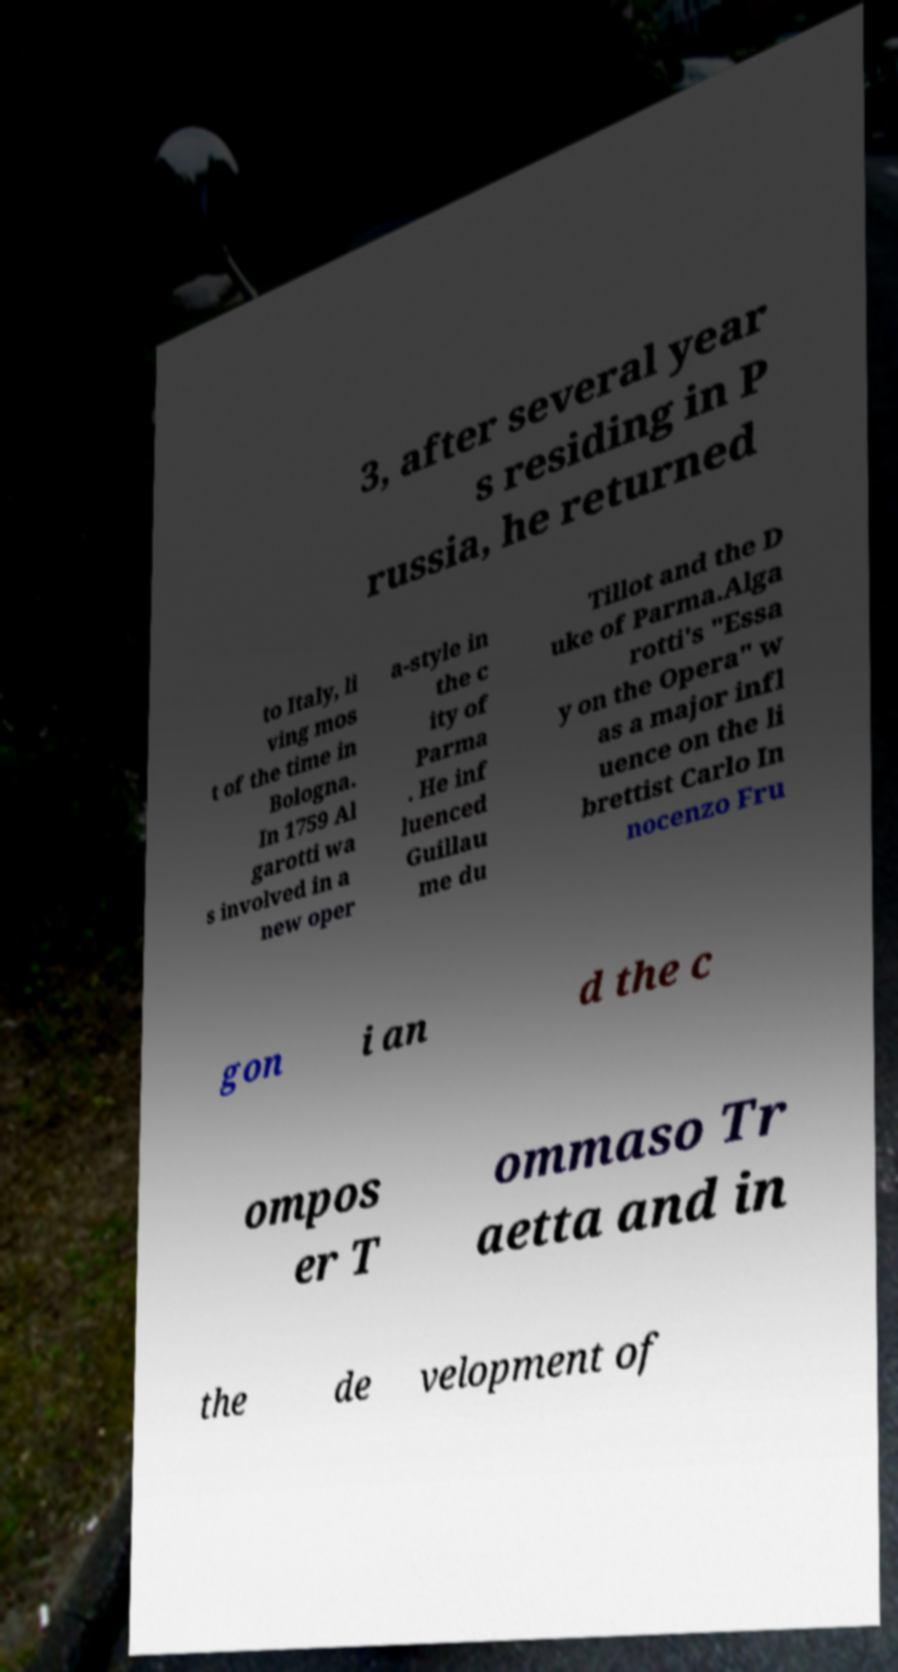Please identify and transcribe the text found in this image. 3, after several year s residing in P russia, he returned to Italy, li ving mos t of the time in Bologna. In 1759 Al garotti wa s involved in a new oper a-style in the c ity of Parma . He inf luenced Guillau me du Tillot and the D uke of Parma.Alga rotti's "Essa y on the Opera" w as a major infl uence on the li brettist Carlo In nocenzo Fru gon i an d the c ompos er T ommaso Tr aetta and in the de velopment of 